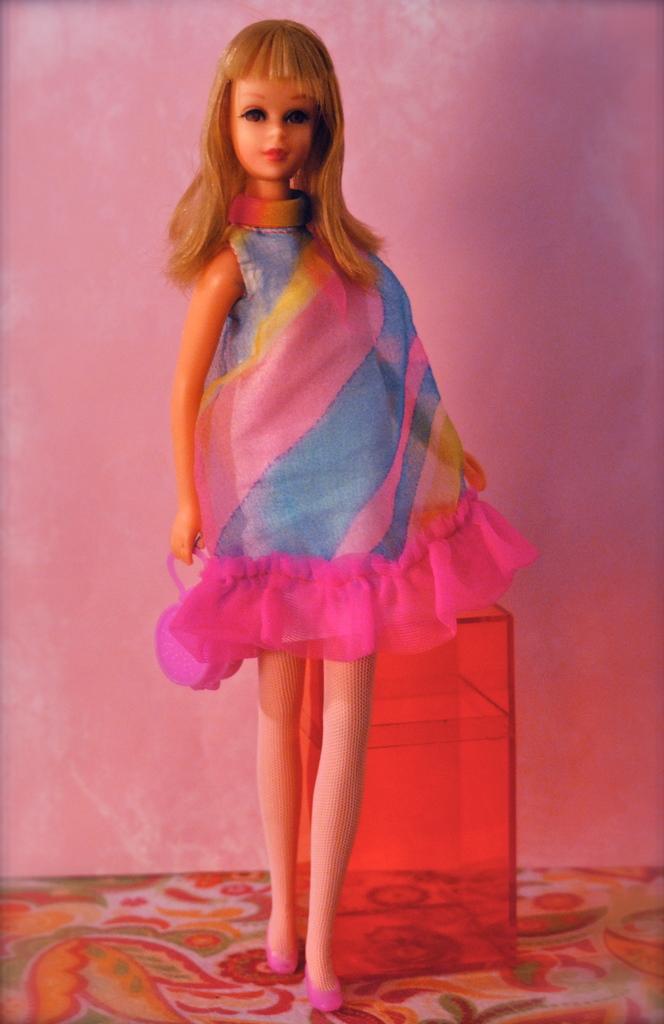Please provide a concise description of this image. In this image, I can see a barbie doll with a colorful dress and shoes. This looks like a red color box. I think this is the wall. This looks like a cloth with a design on it. 